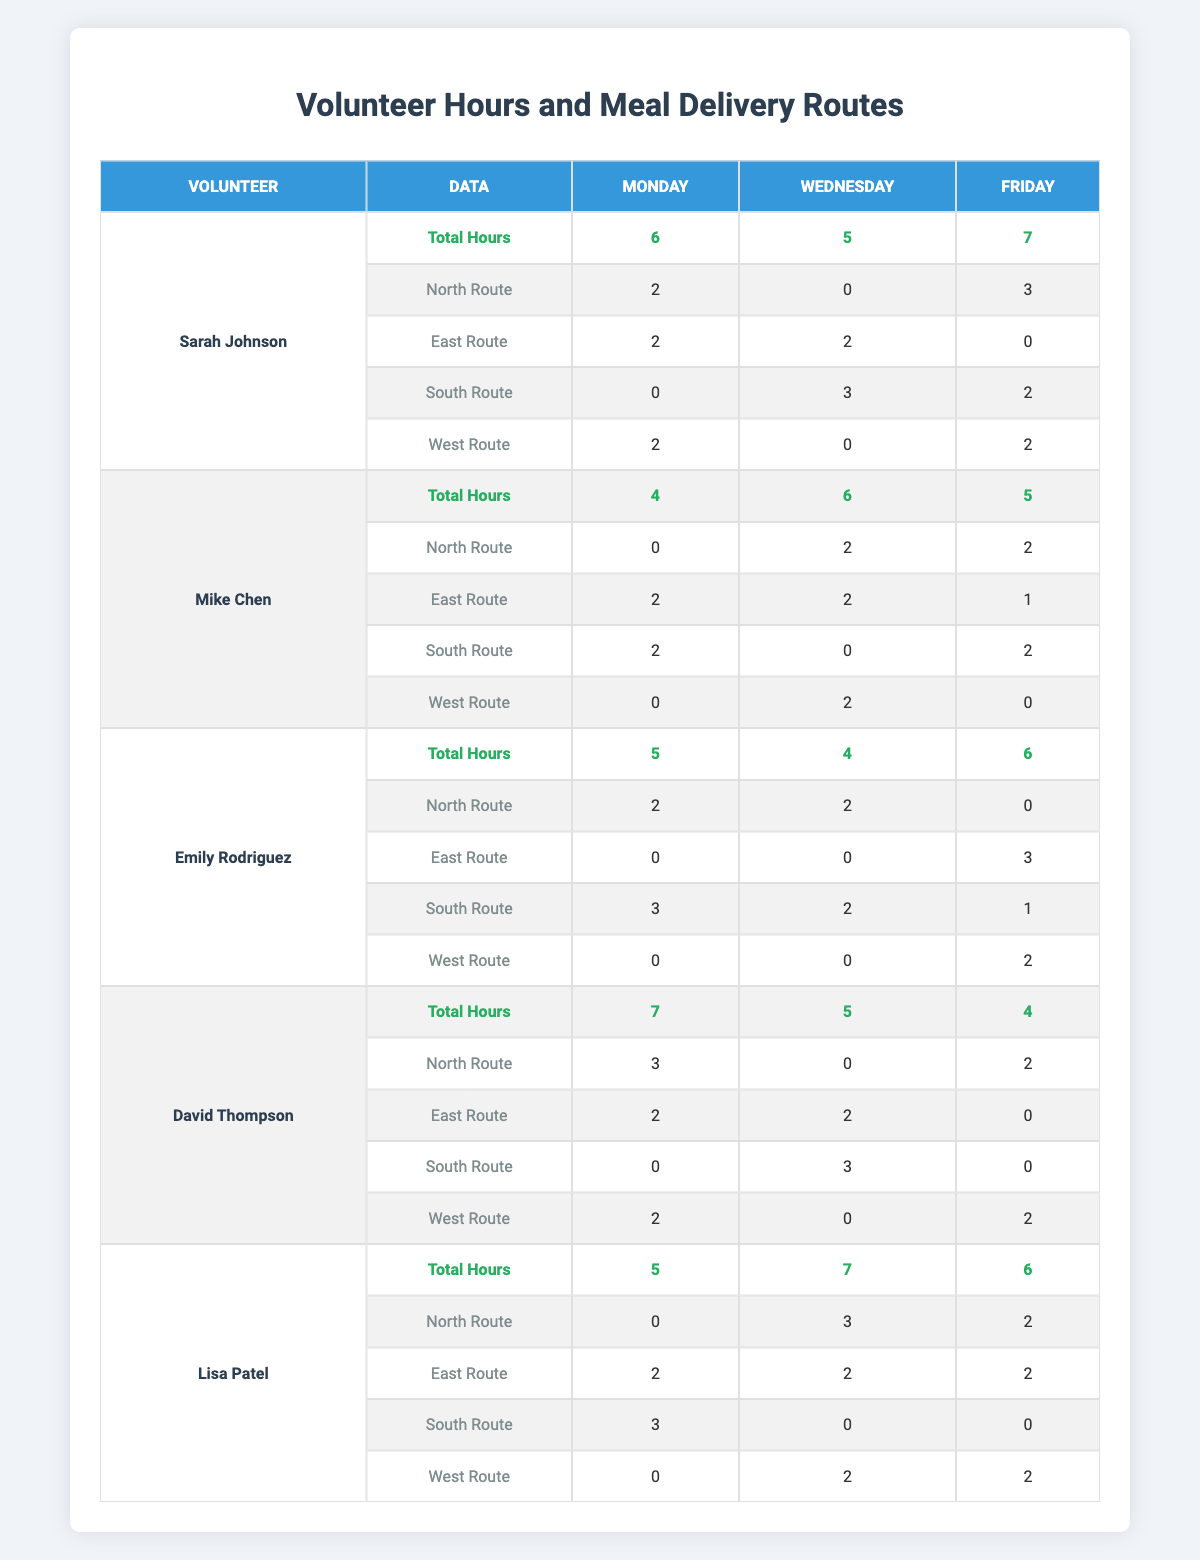What is the total number of volunteer hours recorded for Sarah Johnson? According to the table, Sarah Johnson has a total of 6 hours on Monday, 5 hours on Wednesday, and 7 hours on Friday. We sum these values: 6 + 5 + 7 = 18.
Answer: 18 Which route did Mike Chen deliver the most meals on Friday? Looking at Mike Chen's Friday data, he delivered 2 meals via the North Route, 1 via the East Route, 2 via the South Route, and 0 via the West Route. The highest value is 2, which is for both the North and South Routes.
Answer: North and South Routes Who contributed the least total hours? Analyzing the total hours of each volunteer, Mike Chen has 15 hours (4 + 6 + 5), which is less than the other volunteers.
Answer: Mike Chen What is the average number of hours worked by Lisa Patel across all days? Lisa Patel worked 5 hours on Monday, 7 hours on Wednesday, and 6 hours on Friday. The sum is 5 + 7 + 6 = 18 and the average is 18 / 3 = 6.
Answer: 6 Did Emily Rodriguez deliver more meals on the South Route than the East Route on Wednesday? On Wednesday, Emily delivered 2 meals on the South Route and 0 meals on the East Route. Since 2 is greater than 0, she did deliver more on the South Route.
Answer: Yes What is the total number of hours volunteered by each volunteer on Mondays? Adding the Monday hours: Sarah Johnson (6) + Mike Chen (4) + Emily Rodriguez (5) + David Thompson (7) + Lisa Patel (5) equals 27 hours in total.
Answer: 27 Which route had the highest number of total meals delivered on Wednesday across all volunteers? On Wednesday, we find totals for each route: North (2 + 0 + 2 + 0 + 3 = 7), East (2 + 2 + 0 + 2 + 2 = 8), South (3 + 0 + 2 + 3 + 0 = 8), West (0 + 2 + 0 + 0 + 2 = 4). The highest is the East Route with 8 meals.
Answer: East Route Combine Mike Chen and Lisa Patel’s total hours for Monday. What do you get? Mike Chen volunteered 4 hours and Lisa Patel volunteered 5 hours on Monday. Summing these gives us 4 + 5 = 9 hours total.
Answer: 9 Who delivered the highest number of meals on the North Route across all days? Examining the North Route for each volunteer across all days shows Sarah delivered 5, Mike 4, Emily 4, David 5, and Lisa 5. The greatest delivery was 5 meals from Sarah, David, and Lisa.
Answer: Sarah, David, and Lisa What is the total number of meals delivered on the South Route for Fridays across all volunteers? The South Route data for Friday shows: Sarah (2), Mike (2), Emily (1), David (0), and Lisa (0). Summing these gives 2 + 2 + 1 + 0 + 0 = 5 meals total on that day.
Answer: 5 